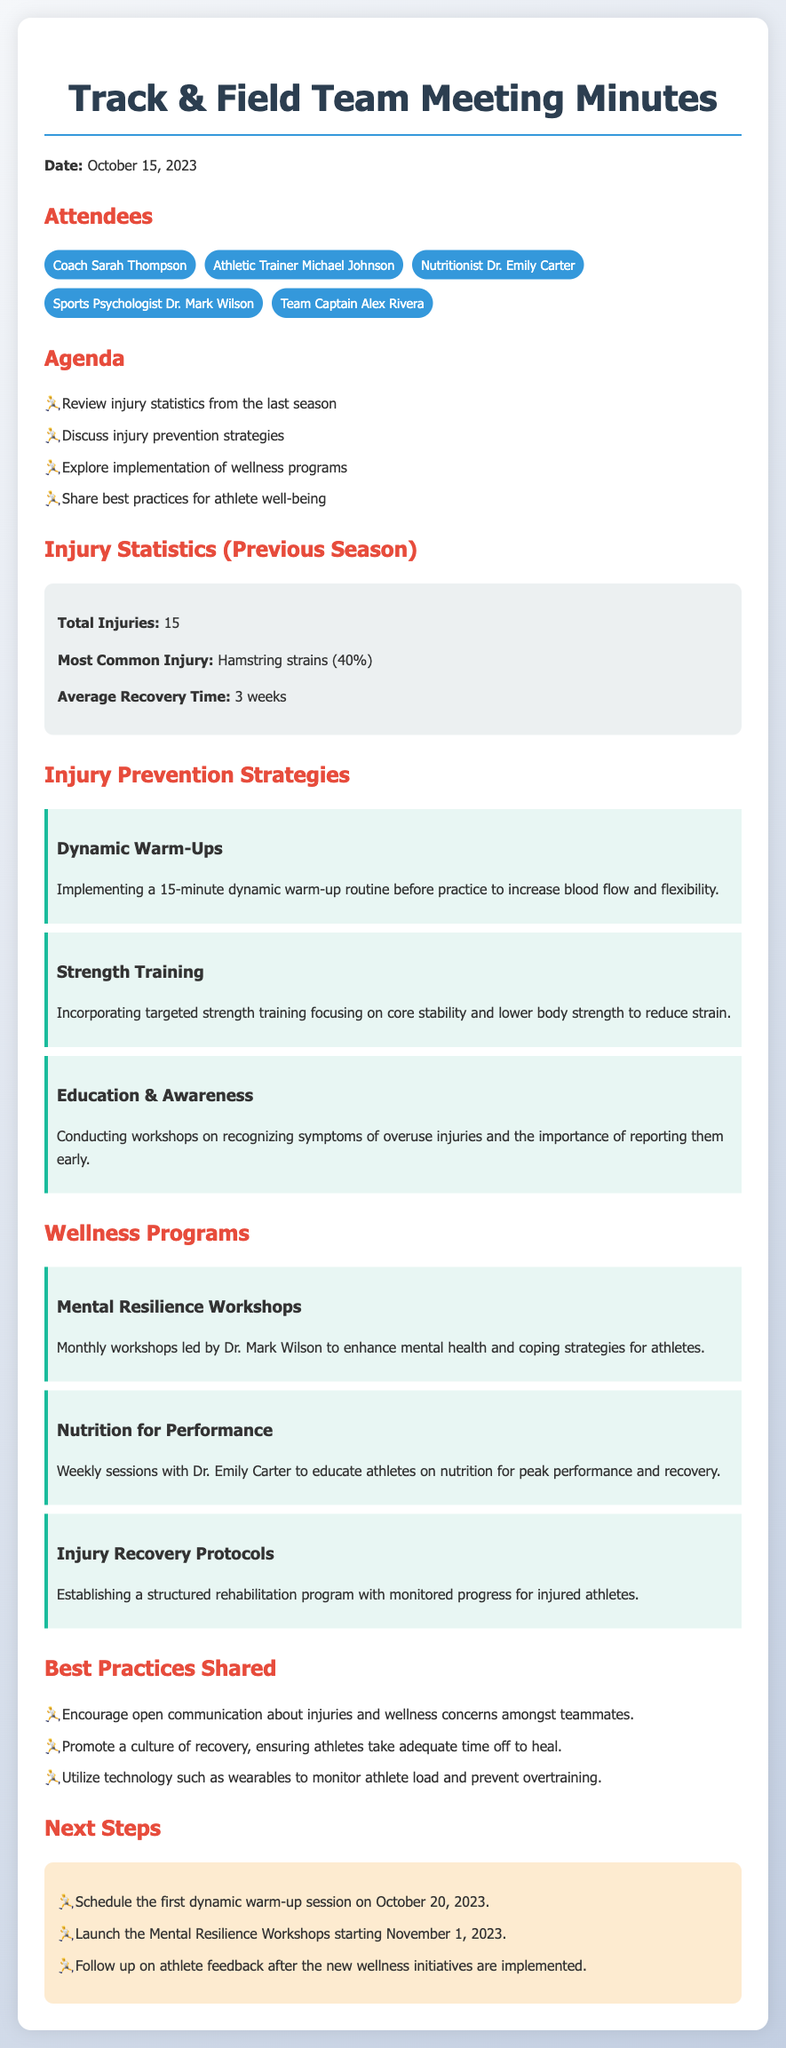what date was the meeting held? The meeting was held on October 15, 2023, as stated at the beginning of the document.
Answer: October 15, 2023 who is the Team Captain? The Team Captain is mentioned in the list of attendees.
Answer: Alex Rivera what was the most common injury? The document specifies that the most common injury was hamstring strains.
Answer: Hamstring strains how many total injuries were reported? The total number of injuries is provided in the injury statistics section of the document.
Answer: 15 what is one of the wellness programs mentioned? The document lists various wellness programs, one example being the Mental Resilience Workshops.
Answer: Mental Resilience Workshops what is the average recovery time? The average recovery time is included in the injury statistics.
Answer: 3 weeks why is education & awareness important in injury prevention? This strategy emphasizes recognizing symptoms early and promotes reporting them, hence preventing further issues.
Answer: To recognize symptoms and report them early when is the first dynamic warm-up session scheduled? The document indicates the date for the first dynamic warm-up session in the next steps section.
Answer: October 20, 2023 